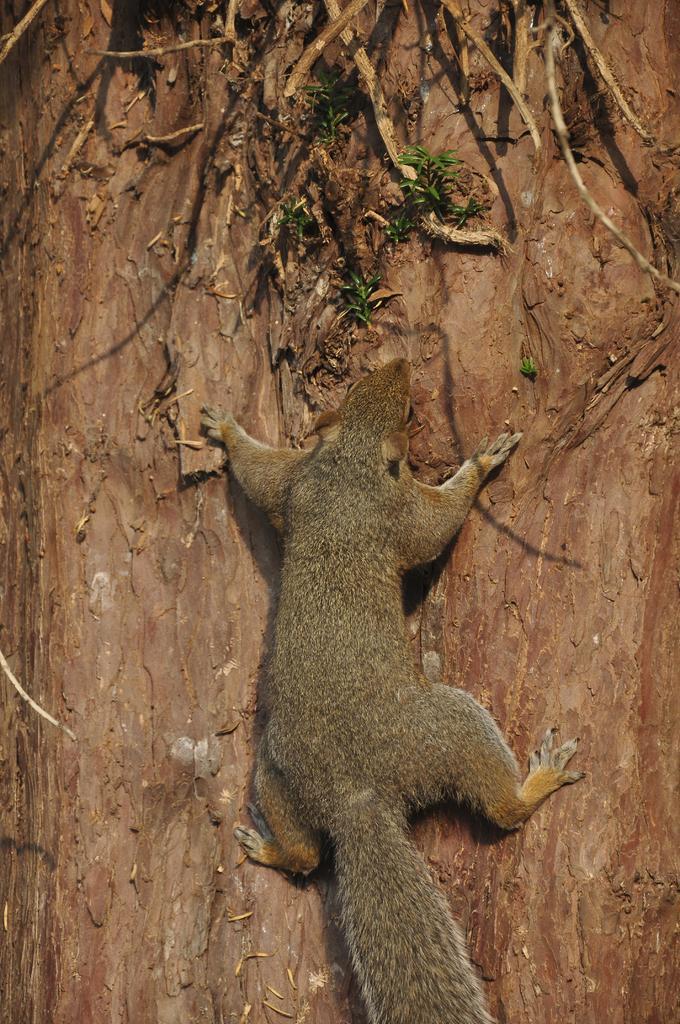Describe this image in one or two sentences. This image consists of a squirrel climbing a tree. 